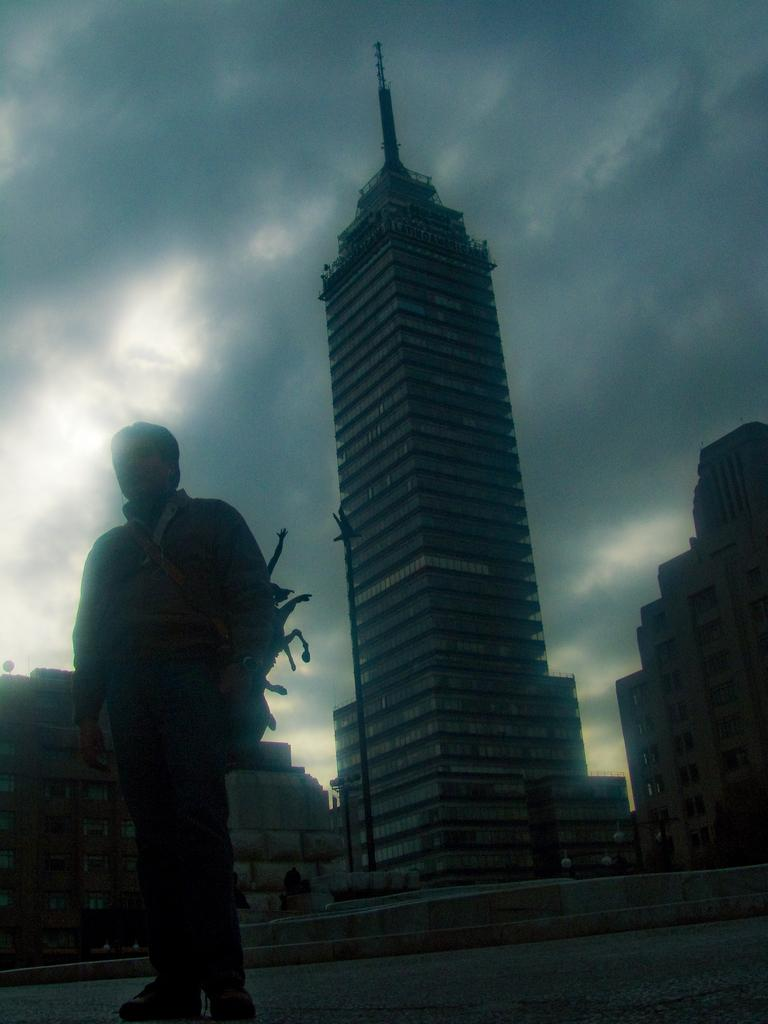What is the main subject of the image? There is a person in the image. What type of structures can be seen in the background? There are buildings and houses in the image. What type of lumber is the person carrying in the image? There is no lumber present in the image. What color is the shirt worn by the person in the image? The provided facts do not mention the color of the person's shirt, so we cannot determine that information from the image. 